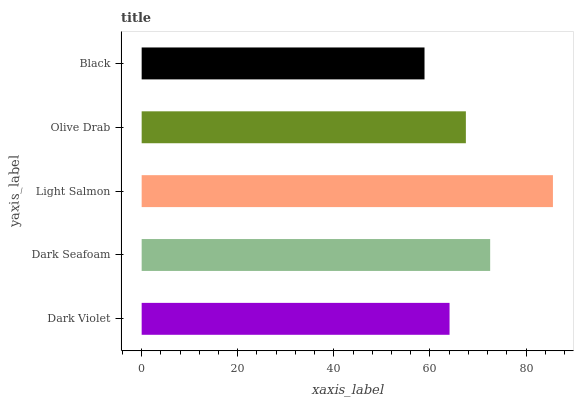Is Black the minimum?
Answer yes or no. Yes. Is Light Salmon the maximum?
Answer yes or no. Yes. Is Dark Seafoam the minimum?
Answer yes or no. No. Is Dark Seafoam the maximum?
Answer yes or no. No. Is Dark Seafoam greater than Dark Violet?
Answer yes or no. Yes. Is Dark Violet less than Dark Seafoam?
Answer yes or no. Yes. Is Dark Violet greater than Dark Seafoam?
Answer yes or no. No. Is Dark Seafoam less than Dark Violet?
Answer yes or no. No. Is Olive Drab the high median?
Answer yes or no. Yes. Is Olive Drab the low median?
Answer yes or no. Yes. Is Dark Seafoam the high median?
Answer yes or no. No. Is Light Salmon the low median?
Answer yes or no. No. 